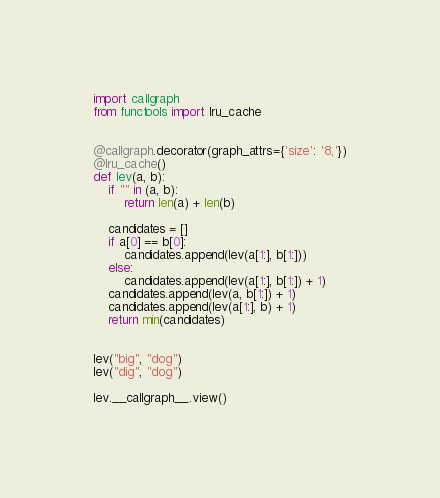<code> <loc_0><loc_0><loc_500><loc_500><_Python_>import callgraph
from functools import lru_cache


@callgraph.decorator(graph_attrs={'size': '8,'})
@lru_cache()
def lev(a, b):
    if "" in (a, b):
        return len(a) + len(b)

    candidates = []
    if a[0] == b[0]:
        candidates.append(lev(a[1:], b[1:]))
    else:
        candidates.append(lev(a[1:], b[1:]) + 1)
    candidates.append(lev(a, b[1:]) + 1)
    candidates.append(lev(a[1:], b) + 1)
    return min(candidates)


lev("big", "dog")
lev("dig", "dog")

lev.__callgraph__.view()
</code> 